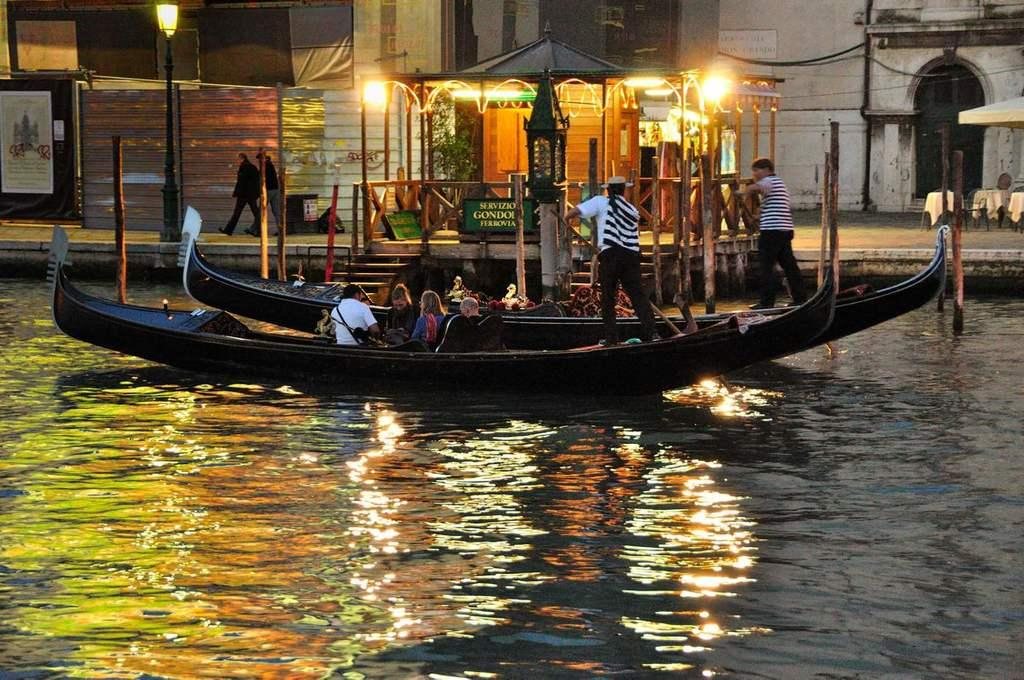What is the primary element in the image? There is water in the image. What other subjects can be seen in the image? There are people, boats, buildings, and street lamps visible in the image. Where is the banner located in the image? The banner is on the left side of the image. What type of arch can be seen in the image? There is no arch present in the image. How does the pain affect the people in the image? There is no mention of pain in the image, as it features water, people, boats, buildings, street lamps, and a banner. 